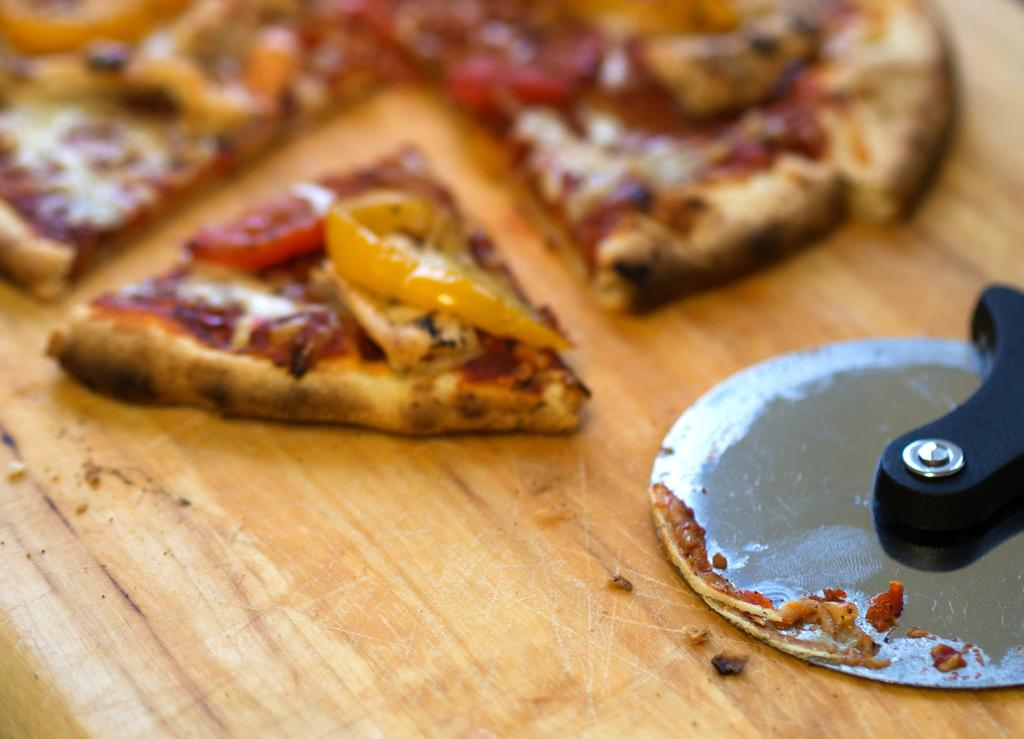What is present at the bottom of the image? There is a table at the bottom of the image. What is on the table in the image? There is a pizza and a pizza cutter on the table. What type of treatment is being administered to the pizza in the image? There is no treatment being administered to the pizza in the image; it is simply sitting on the table. 